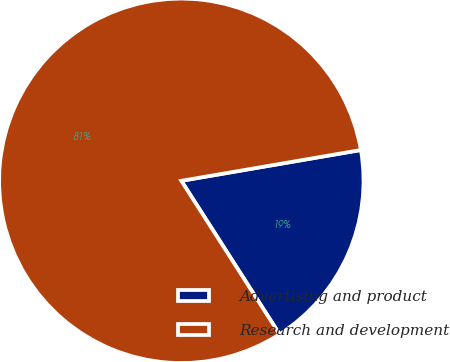<chart> <loc_0><loc_0><loc_500><loc_500><pie_chart><fcel>Advertising and product<fcel>Research and development<nl><fcel>18.64%<fcel>81.36%<nl></chart> 